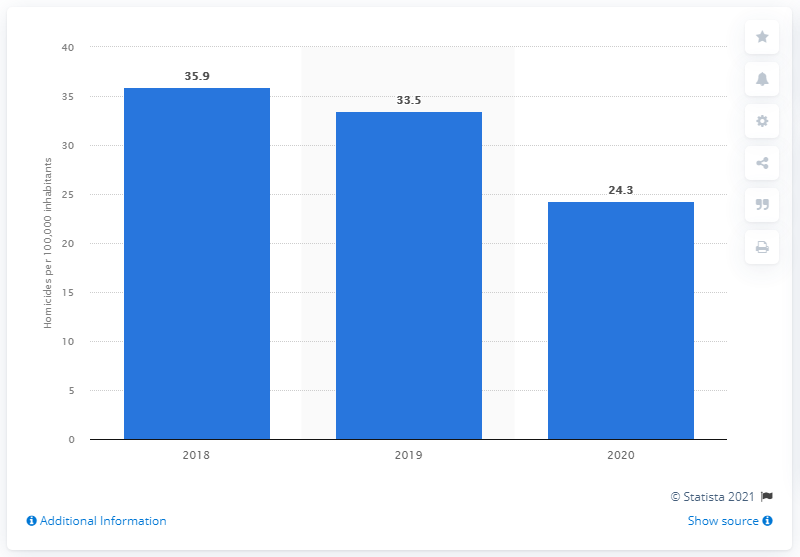Draw attention to some important aspects in this diagram. The murder rate in Belize a year earlier was 33.5. 